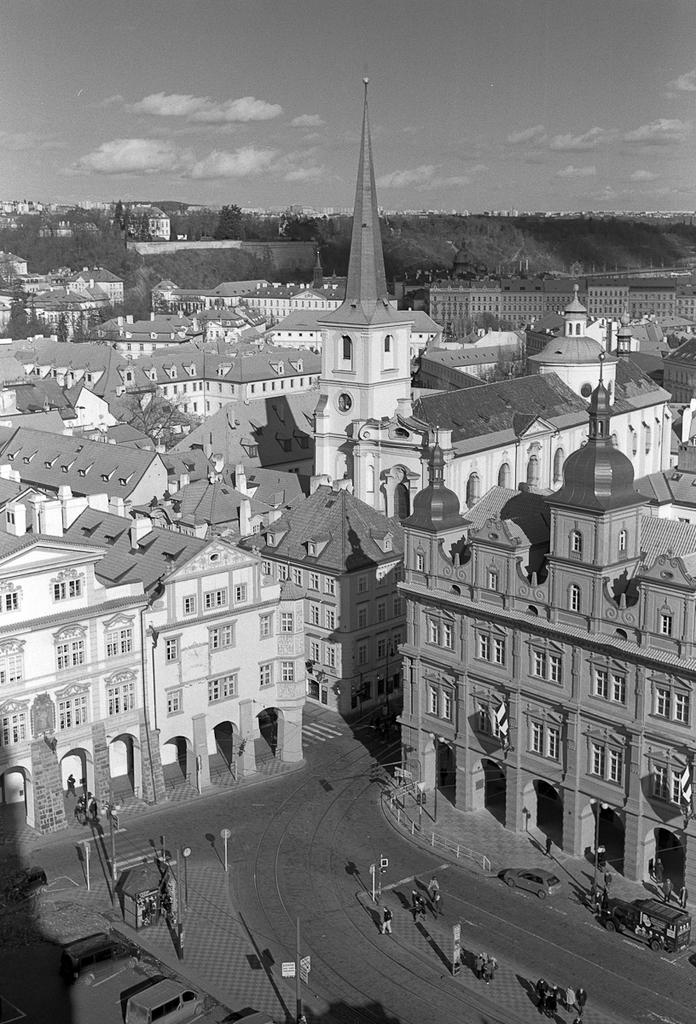What is the color scheme of the image? The image is black and white. What type of structures can be seen in the image? There are buildings in the image. What other elements are present in the image besides buildings? There are trees, vehicles, people, poles on the road, and the sky visible in the background. Can you tell me what question the doll is asking in the middle of the image? There is no doll present in the image, and therefore no such question can be observed. 